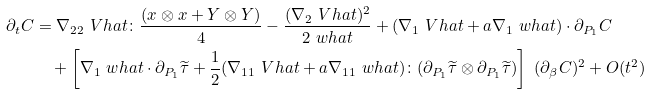<formula> <loc_0><loc_0><loc_500><loc_500>\partial _ { t } C & = \nabla _ { 2 2 } \ V h a t \colon \frac { ( x \otimes x + Y \otimes Y ) } { 4 } - \frac { ( \nabla _ { 2 } \ V h a t ) ^ { 2 } } { 2 \ w h a t } + ( \nabla _ { 1 } \ V h a t + a \nabla _ { 1 } \ w h a t ) \cdot \partial _ { P _ { 1 } } C \\ & \quad + \left [ \nabla _ { 1 } \ w h a t \cdot \partial _ { P _ { 1 } } \widetilde { \tau } + \frac { 1 } { 2 } ( \nabla _ { 1 1 } \ V h a t + a \nabla _ { 1 1 } \ w h a t ) \colon ( \partial _ { P _ { 1 } } \widetilde { \tau } \otimes \partial _ { P _ { 1 } } \widetilde { \tau } ) \right ] \ ( \partial _ { \beta } C ) ^ { 2 } + O ( t ^ { 2 } )</formula> 